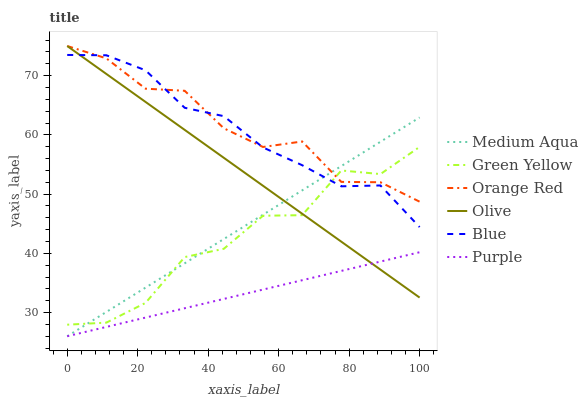Does Purple have the minimum area under the curve?
Answer yes or no. Yes. Does Orange Red have the maximum area under the curve?
Answer yes or no. Yes. Does Medium Aqua have the minimum area under the curve?
Answer yes or no. No. Does Medium Aqua have the maximum area under the curve?
Answer yes or no. No. Is Olive the smoothest?
Answer yes or no. Yes. Is Green Yellow the roughest?
Answer yes or no. Yes. Is Purple the smoothest?
Answer yes or no. No. Is Purple the roughest?
Answer yes or no. No. Does Purple have the lowest value?
Answer yes or no. Yes. Does Olive have the lowest value?
Answer yes or no. No. Does Orange Red have the highest value?
Answer yes or no. Yes. Does Medium Aqua have the highest value?
Answer yes or no. No. Is Purple less than Blue?
Answer yes or no. Yes. Is Orange Red greater than Purple?
Answer yes or no. Yes. Does Medium Aqua intersect Purple?
Answer yes or no. Yes. Is Medium Aqua less than Purple?
Answer yes or no. No. Is Medium Aqua greater than Purple?
Answer yes or no. No. Does Purple intersect Blue?
Answer yes or no. No. 